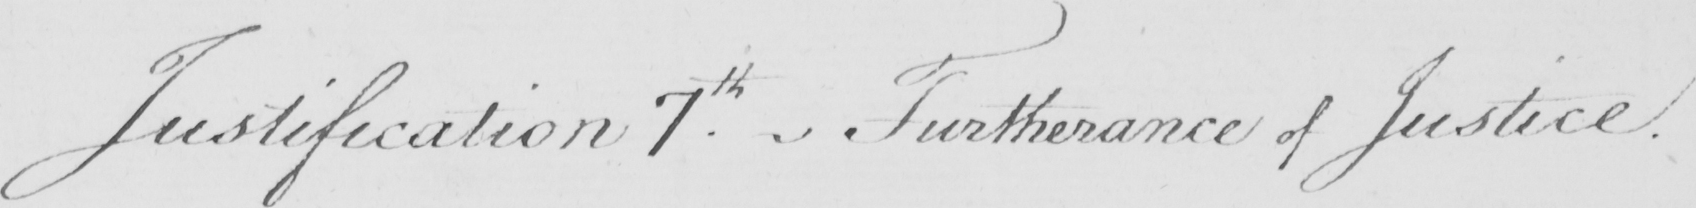Can you read and transcribe this handwriting? Justification 7.th Furtherance of Justice . 